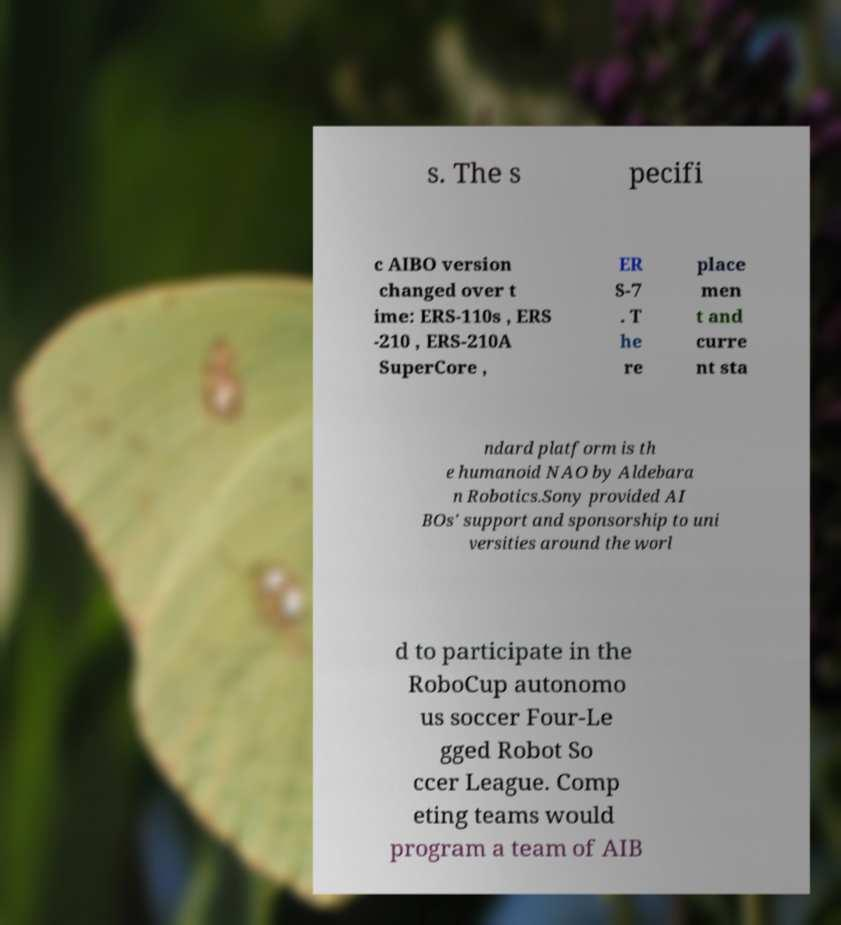Can you read and provide the text displayed in the image?This photo seems to have some interesting text. Can you extract and type it out for me? s. The s pecifi c AIBO version changed over t ime: ERS-110s , ERS -210 , ERS-210A SuperCore , ER S-7 . T he re place men t and curre nt sta ndard platform is th e humanoid NAO by Aldebara n Robotics.Sony provided AI BOs' support and sponsorship to uni versities around the worl d to participate in the RoboCup autonomo us soccer Four-Le gged Robot So ccer League. Comp eting teams would program a team of AIB 